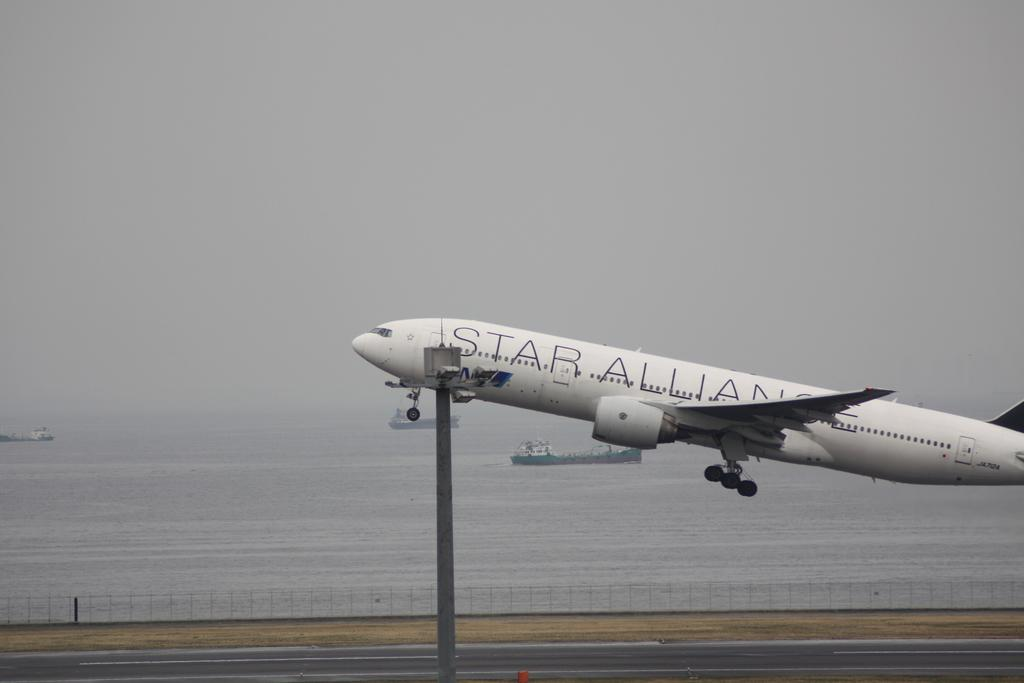<image>
Offer a succinct explanation of the picture presented. A large Star Alliance passenger jet is just taking off from a runway by the ocean. 